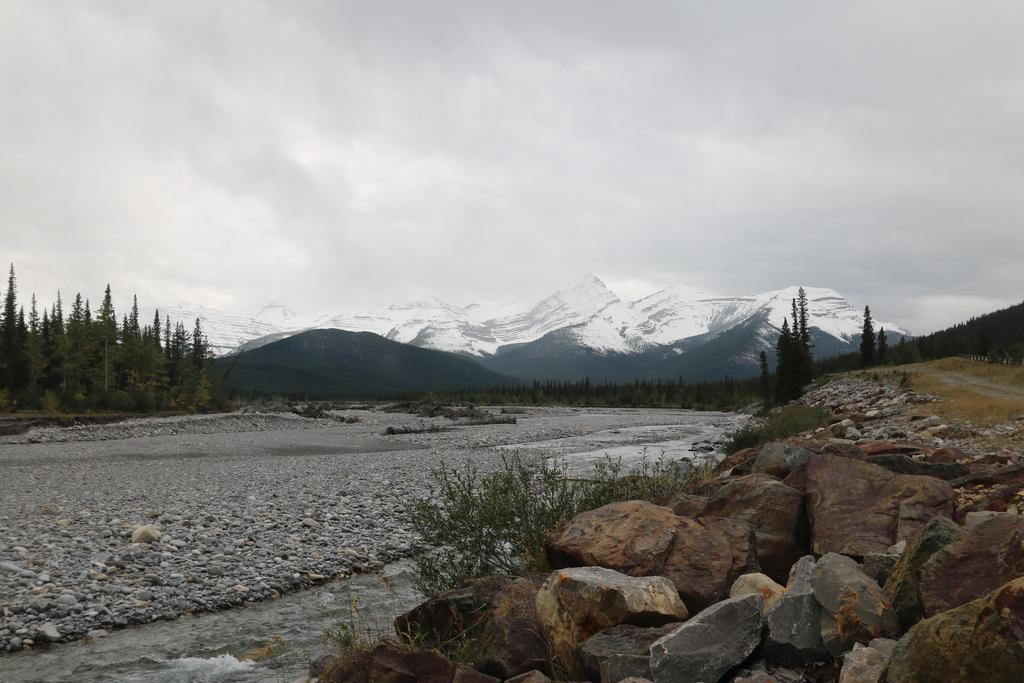What can be seen on the ground in the center of the image? There are stones on the ground in the center of the image. What type of natural features are visible in the background of the image? There are mountains and trees in the background of the image. What is the condition of the sky in the background of the image? The sky is cloudy in the background of the image. What type of sea creature can be seen swimming near the governor in the image? There is no sea or governor present in the image; it features stones on the ground, mountains, trees, and a cloudy sky. 